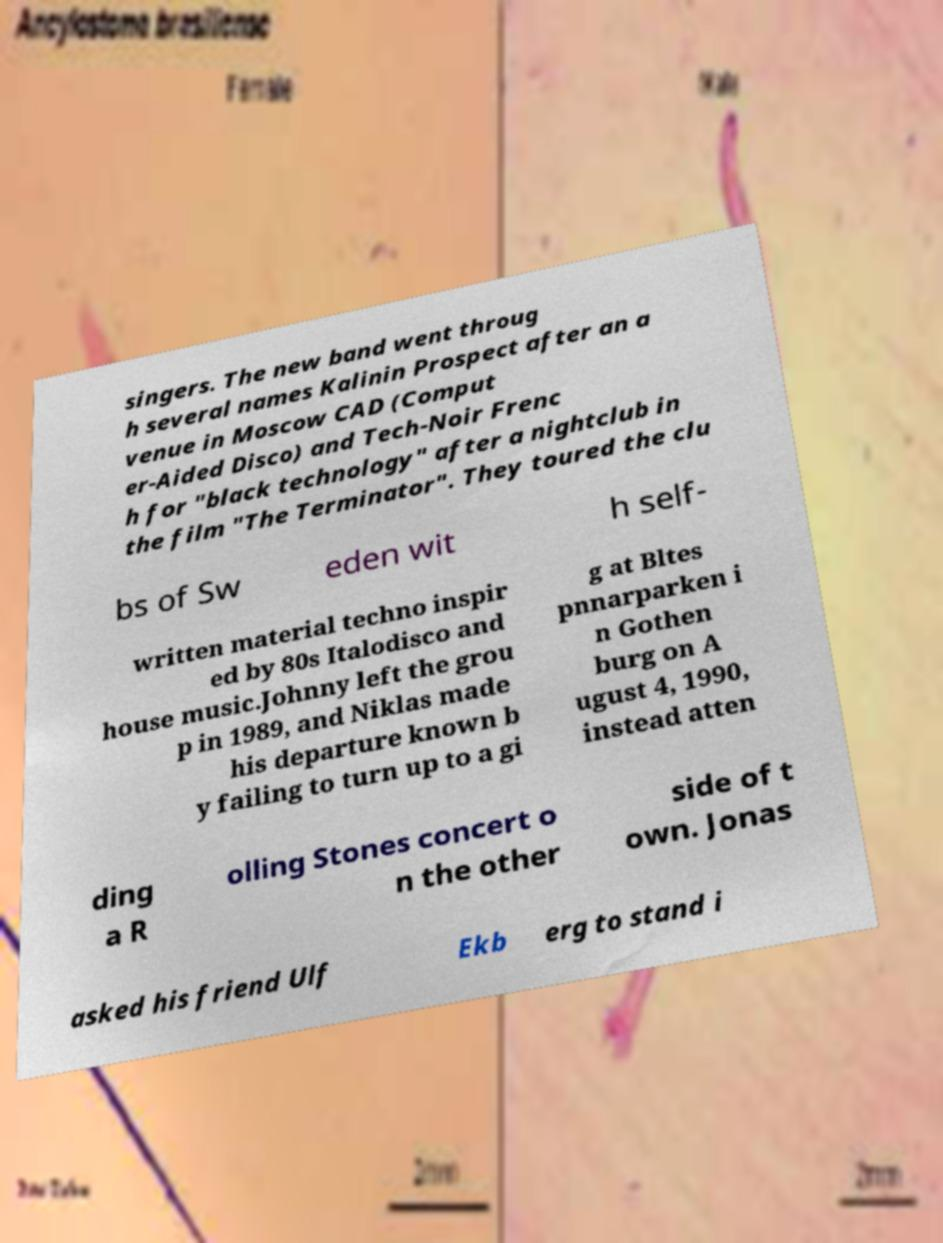Could you extract and type out the text from this image? singers. The new band went throug h several names Kalinin Prospect after an a venue in Moscow CAD (Comput er-Aided Disco) and Tech-Noir Frenc h for "black technology" after a nightclub in the film "The Terminator". They toured the clu bs of Sw eden wit h self- written material techno inspir ed by 80s Italodisco and house music.Johnny left the grou p in 1989, and Niklas made his departure known b y failing to turn up to a gi g at Bltes pnnarparken i n Gothen burg on A ugust 4, 1990, instead atten ding a R olling Stones concert o n the other side of t own. Jonas asked his friend Ulf Ekb erg to stand i 